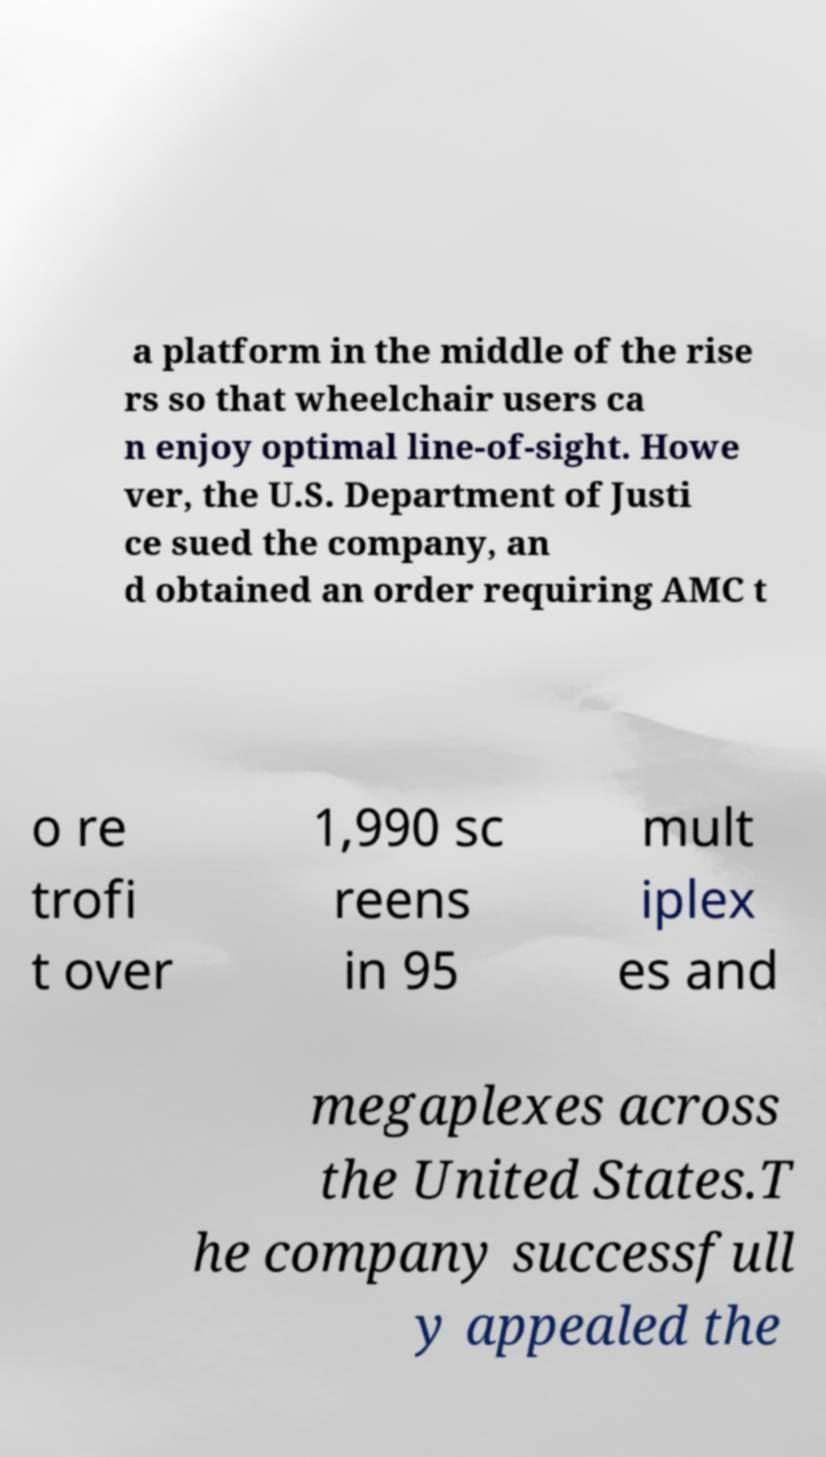What messages or text are displayed in this image? I need them in a readable, typed format. a platform in the middle of the rise rs so that wheelchair users ca n enjoy optimal line-of-sight. Howe ver, the U.S. Department of Justi ce sued the company, an d obtained an order requiring AMC t o re trofi t over 1,990 sc reens in 95 mult iplex es and megaplexes across the United States.T he company successfull y appealed the 